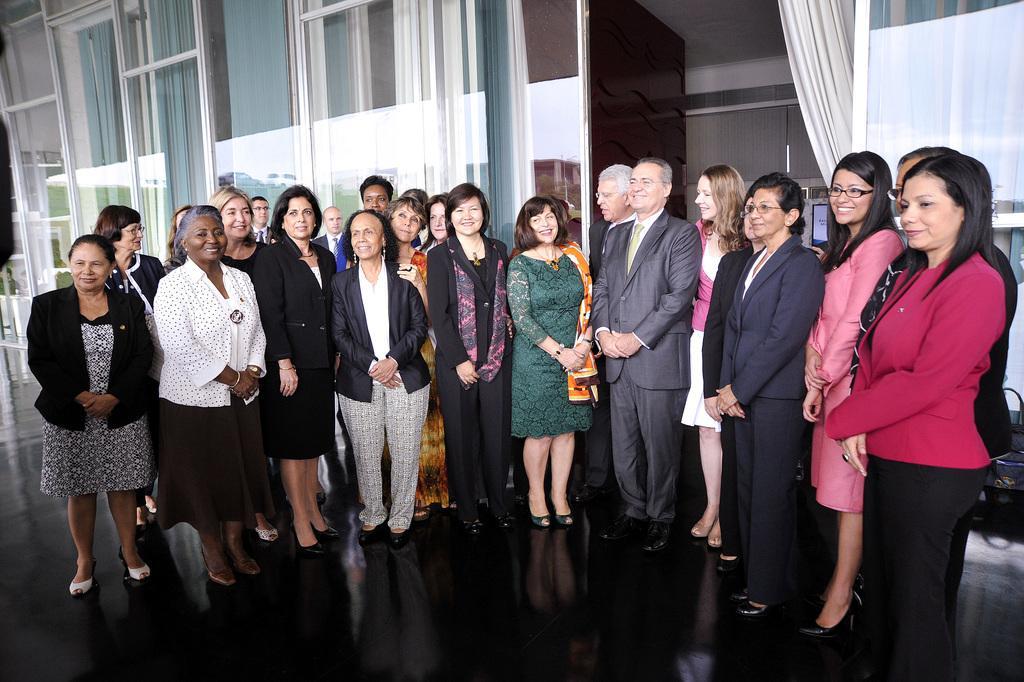Can you describe this image briefly? There are group of people standing and smiling. These are the curtains hanging to the hanger. I can see the glass doors. Here is the floor. 